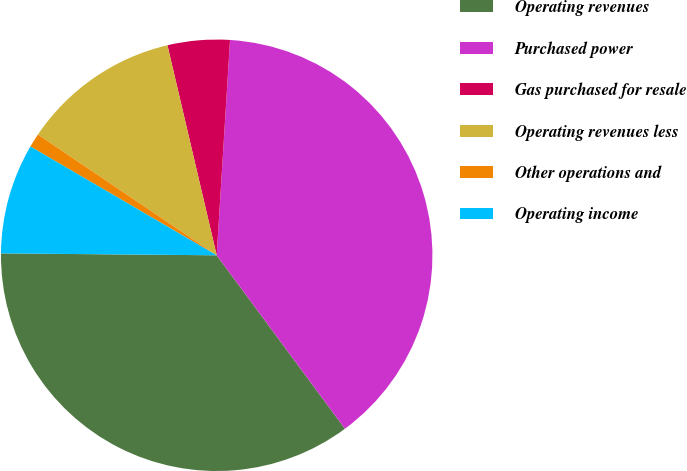<chart> <loc_0><loc_0><loc_500><loc_500><pie_chart><fcel>Operating revenues<fcel>Purchased power<fcel>Gas purchased for resale<fcel>Operating revenues less<fcel>Other operations and<fcel>Operating income<nl><fcel>35.27%<fcel>38.88%<fcel>4.65%<fcel>11.88%<fcel>1.04%<fcel>8.27%<nl></chart> 